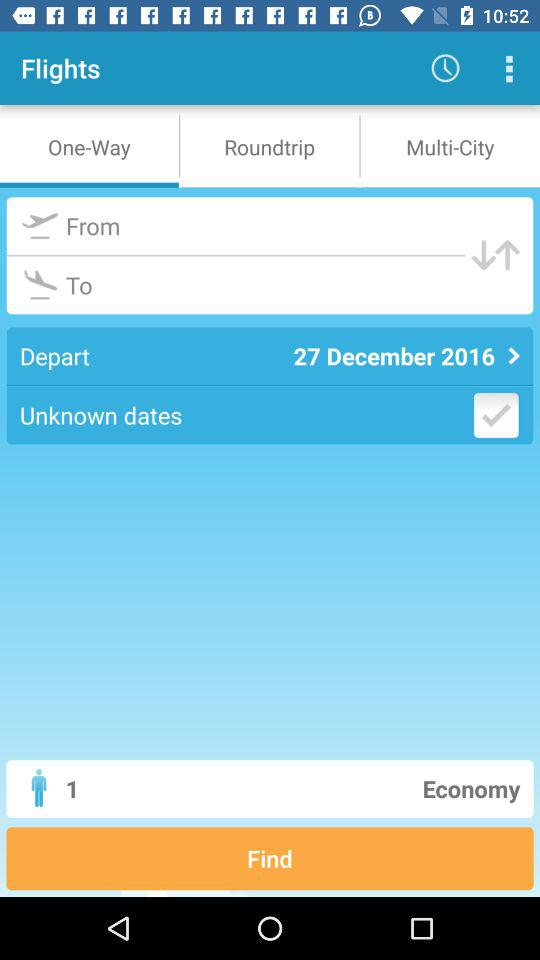What is the number of passengers? The number of passengers is 1. 